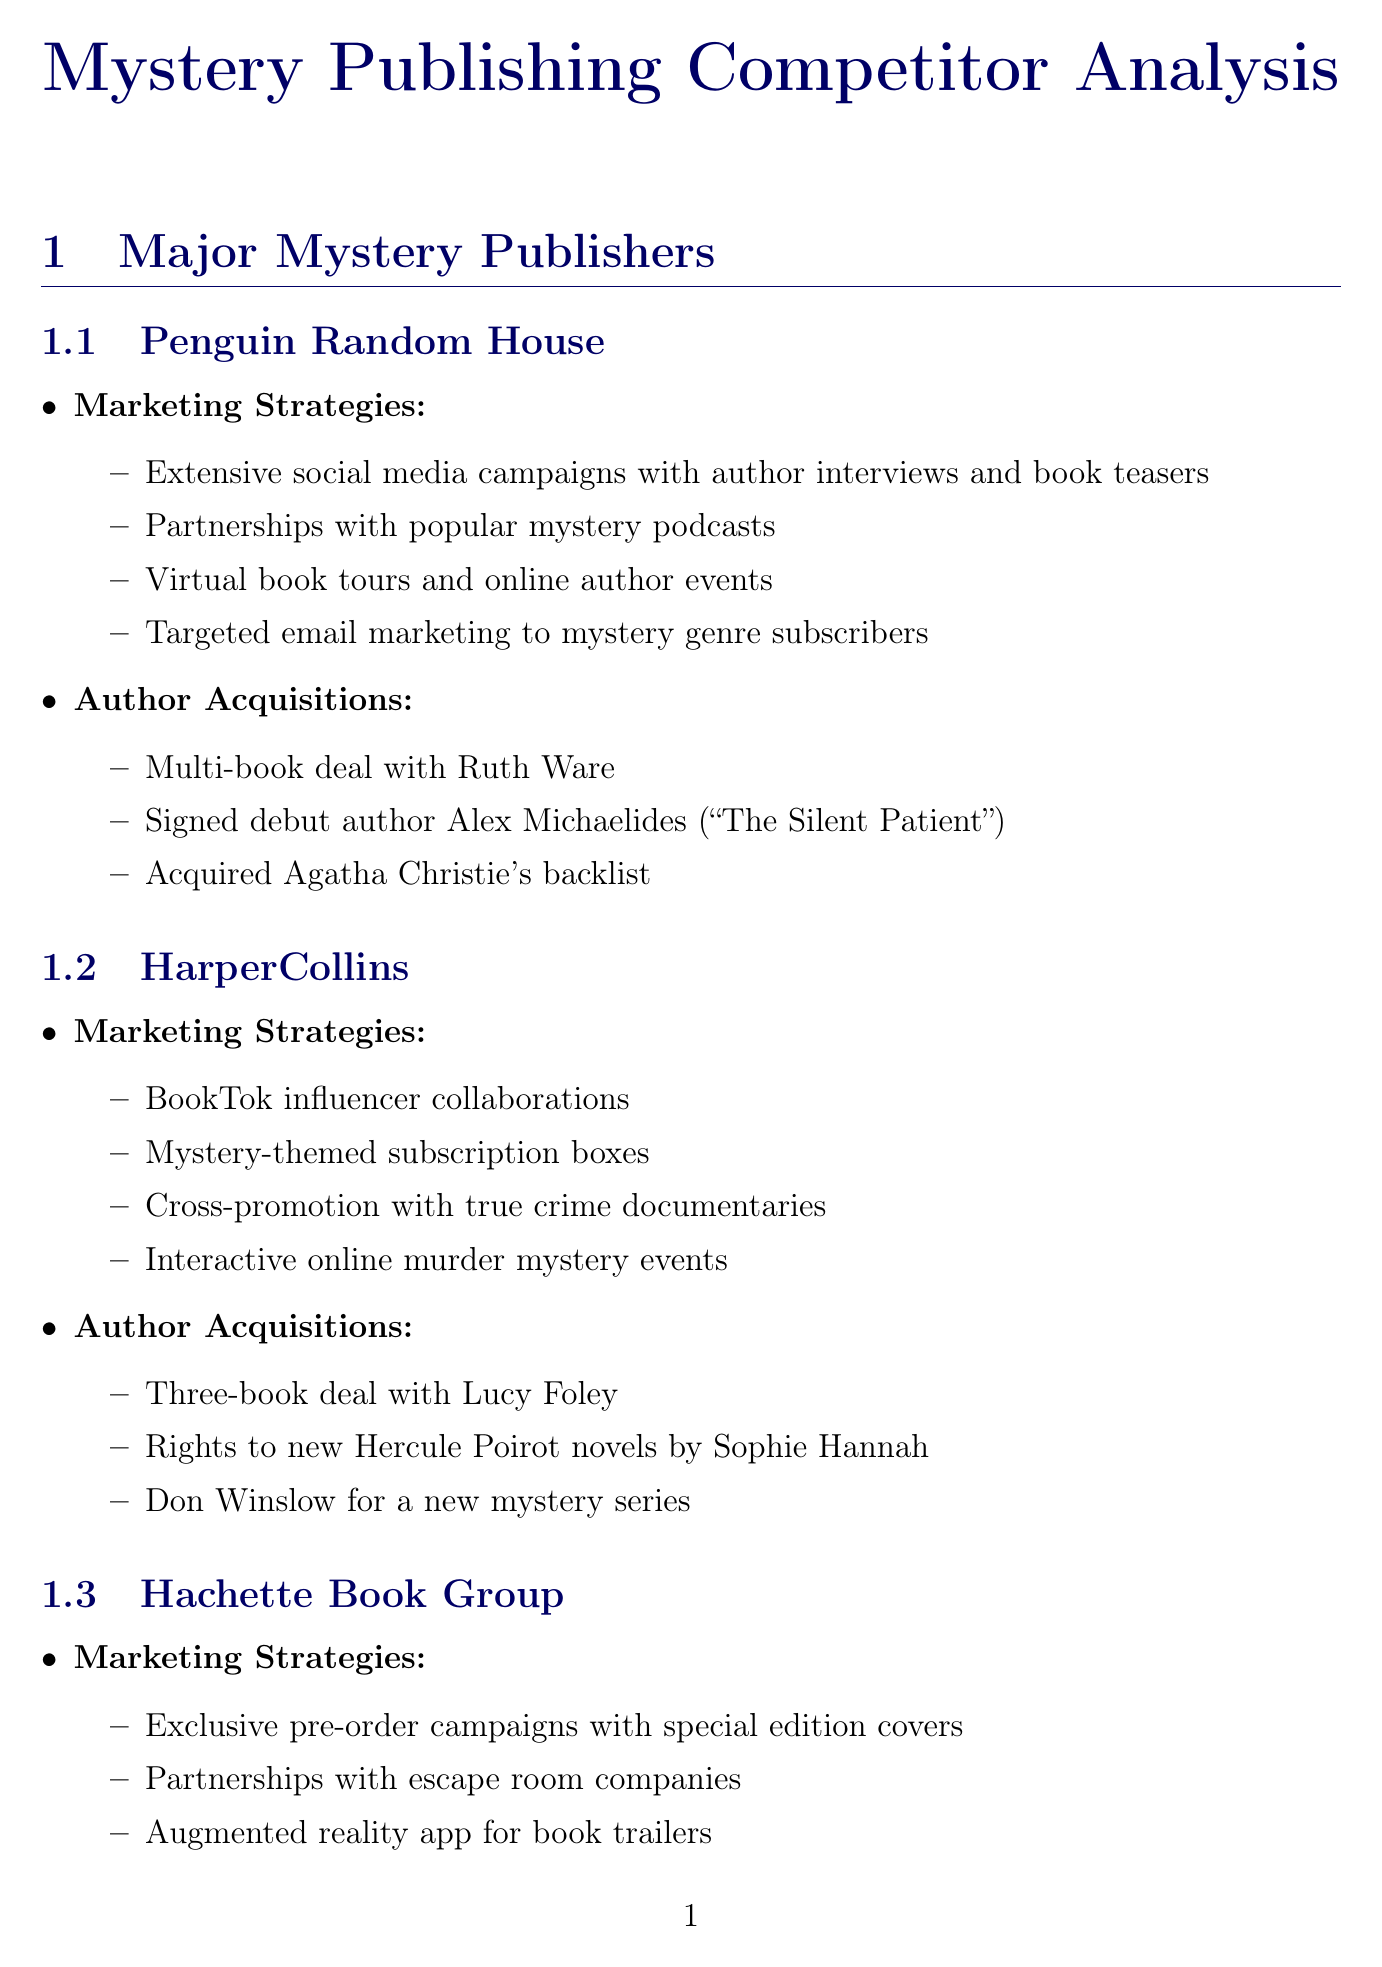What are the marketing strategies utilized by Penguin Random House? This question asks for specific marketing strategies provided in the document under the Penguin Random House section.
Answer: Extensive social media campaigns featuring author interviews and book teasers, Partnerships with popular mystery podcasts for sponsored content, Virtual book tours and online author events, Targeted email marketing to mystery genre subscribers How many books did HarperCollins sign with Lucy Foley? This question refers to the author acquisitions section under HarperCollins and what specific acquisition was made with Lucy Foley.
Answer: Three-book deal What is the market share of Hachette Book Group? This question inquires specifically about the market share figure listed for Hachette Book Group in the market share data section.
Answer: 18% What upcoming release is authored by Gillian Flynn? This question seeks to identify a specific author's upcoming book mentioned in the upcoming releases section.
Answer: The Midnight Whisper Which publisher acquired the rights to new Hercule Poirot novels? This asks for the specific publisher that has acquisition rights to Hercule Poirot novels, which requires understanding from the author acquisitions section.
Answer: HarperCollins What is a notable industry trend mentioned in the document? This question asks for any trend listed in the industry trends section, allowing for a range of acceptable answers.
Answer: Increased focus on diverse voices in mystery fiction What platform is mentioned for collaborations by HarperCollins? This question looks for a specific platform indicated in the marketing strategies for HarperCollins.
Answer: BookTok How many publishers are listed with market share data? This requires counting the number of publishers mentioned in the market share data section.
Answer: Six 